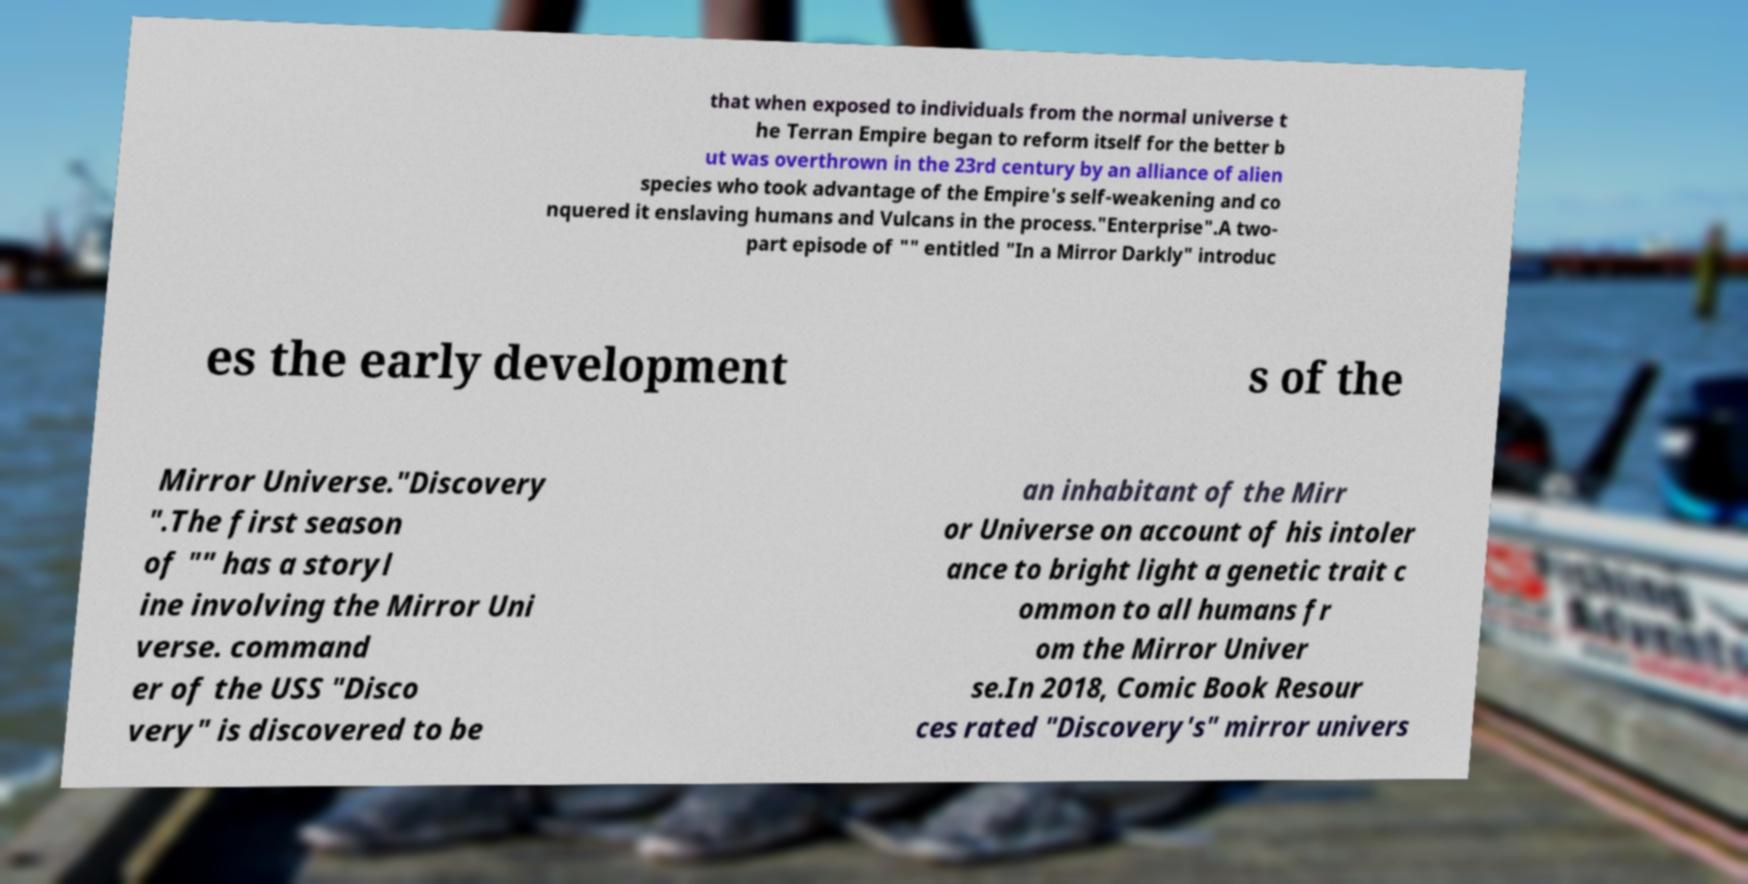Could you assist in decoding the text presented in this image and type it out clearly? that when exposed to individuals from the normal universe t he Terran Empire began to reform itself for the better b ut was overthrown in the 23rd century by an alliance of alien species who took advantage of the Empire's self-weakening and co nquered it enslaving humans and Vulcans in the process."Enterprise".A two- part episode of "" entitled "In a Mirror Darkly" introduc es the early development s of the Mirror Universe."Discovery ".The first season of "" has a storyl ine involving the Mirror Uni verse. command er of the USS "Disco very" is discovered to be an inhabitant of the Mirr or Universe on account of his intoler ance to bright light a genetic trait c ommon to all humans fr om the Mirror Univer se.In 2018, Comic Book Resour ces rated "Discovery's" mirror univers 